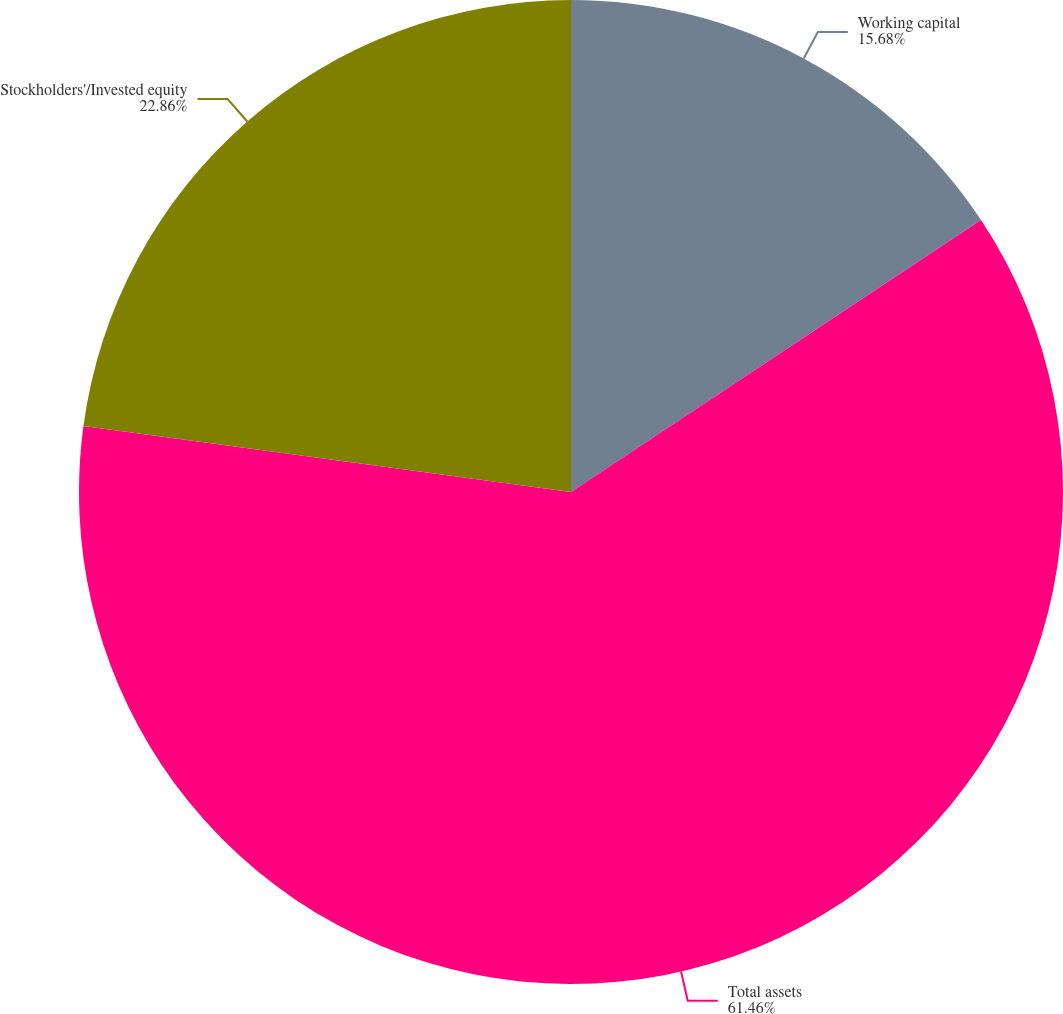Convert chart to OTSL. <chart><loc_0><loc_0><loc_500><loc_500><pie_chart><fcel>Working capital<fcel>Total assets<fcel>Stockholders'/Invested equity<nl><fcel>15.68%<fcel>61.46%<fcel>22.86%<nl></chart> 